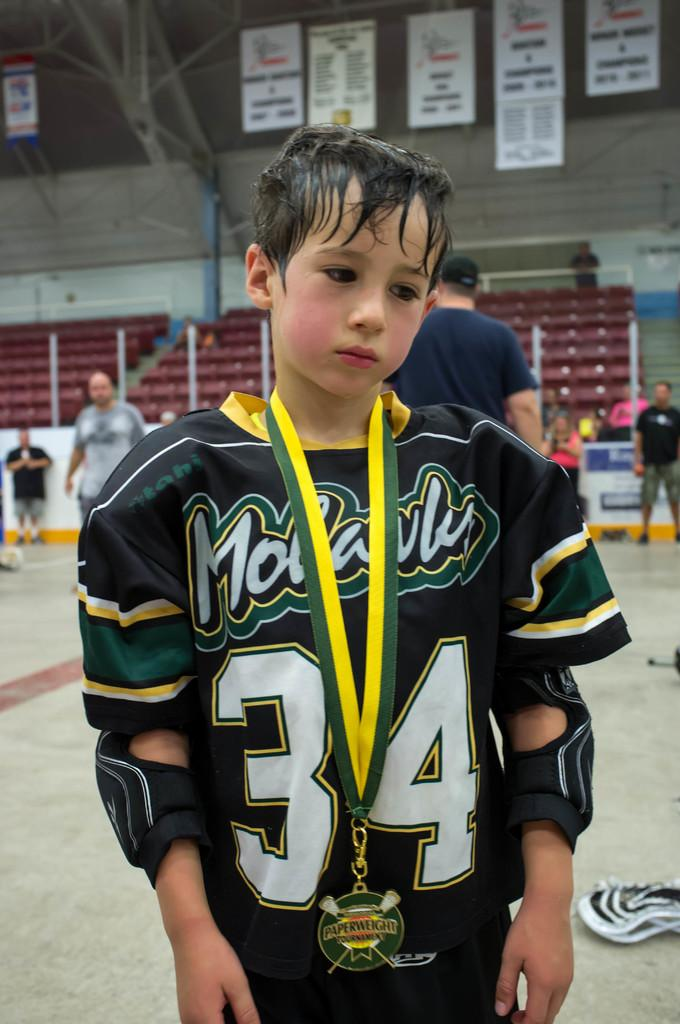<image>
Give a short and clear explanation of the subsequent image. Boy wearing a number 34 jersey while posing for a photo. 